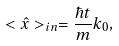Convert formula to latex. <formula><loc_0><loc_0><loc_500><loc_500>< \hat { x } > _ { i n } = \frac { \hbar { t } } { m } k _ { 0 } ,</formula> 